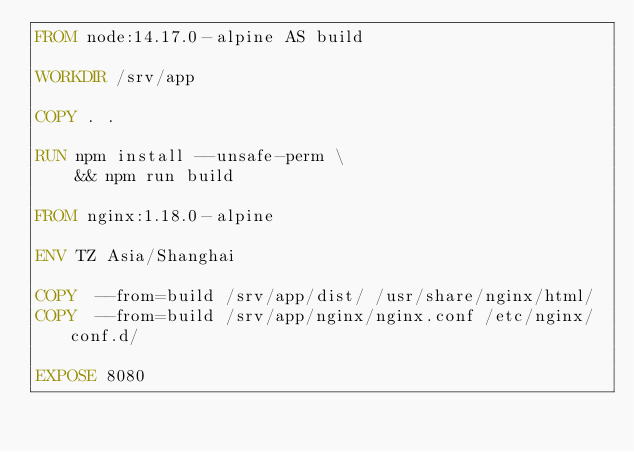Convert code to text. <code><loc_0><loc_0><loc_500><loc_500><_Dockerfile_>FROM node:14.17.0-alpine AS build

WORKDIR /srv/app

COPY . .

RUN npm install --unsafe-perm \
    && npm run build

FROM nginx:1.18.0-alpine

ENV TZ Asia/Shanghai

COPY  --from=build /srv/app/dist/ /usr/share/nginx/html/
COPY  --from=build /srv/app/nginx/nginx.conf /etc/nginx/conf.d/

EXPOSE 8080
</code> 